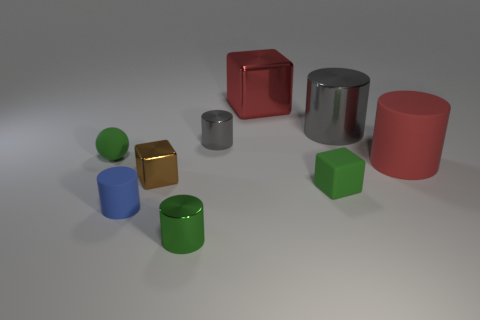There is a blue object that is the same shape as the large gray metallic thing; what size is it?
Your response must be concise. Small. Is the shape of the red rubber object the same as the small brown object?
Provide a short and direct response. No. There is a block that is behind the small green matte object that is behind the brown object; what size is it?
Keep it short and to the point. Large. What color is the other small shiny thing that is the same shape as the red metallic thing?
Make the answer very short. Brown. How many small rubber cubes are the same color as the rubber sphere?
Provide a short and direct response. 1. The green metallic cylinder has what size?
Your answer should be compact. Small. Does the sphere have the same size as the blue rubber cylinder?
Give a very brief answer. Yes. What is the color of the tiny object that is both behind the large rubber object and left of the brown shiny thing?
Give a very brief answer. Green. What number of brown objects are made of the same material as the blue cylinder?
Offer a very short reply. 0. What number of large gray objects are there?
Offer a very short reply. 1. 